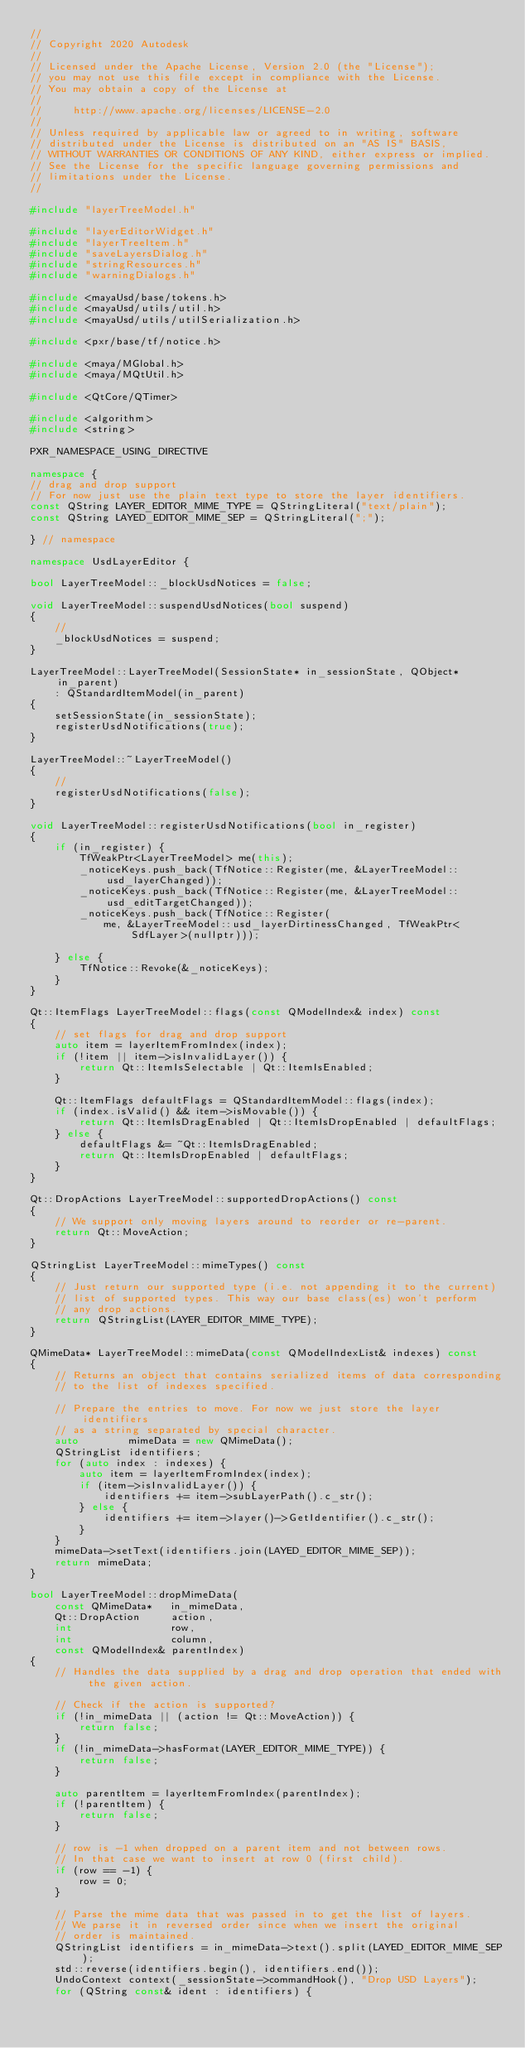Convert code to text. <code><loc_0><loc_0><loc_500><loc_500><_C++_>//
// Copyright 2020 Autodesk
//
// Licensed under the Apache License, Version 2.0 (the "License");
// you may not use this file except in compliance with the License.
// You may obtain a copy of the License at
//
//     http://www.apache.org/licenses/LICENSE-2.0
//
// Unless required by applicable law or agreed to in writing, software
// distributed under the License is distributed on an "AS IS" BASIS,
// WITHOUT WARRANTIES OR CONDITIONS OF ANY KIND, either express or implied.
// See the License for the specific language governing permissions and
// limitations under the License.
//

#include "layerTreeModel.h"

#include "layerEditorWidget.h"
#include "layerTreeItem.h"
#include "saveLayersDialog.h"
#include "stringResources.h"
#include "warningDialogs.h"

#include <mayaUsd/base/tokens.h>
#include <mayaUsd/utils/util.h>
#include <mayaUsd/utils/utilSerialization.h>

#include <pxr/base/tf/notice.h>

#include <maya/MGlobal.h>
#include <maya/MQtUtil.h>

#include <QtCore/QTimer>

#include <algorithm>
#include <string>

PXR_NAMESPACE_USING_DIRECTIVE

namespace {
// drag and drop support
// For now just use the plain text type to store the layer identifiers.
const QString LAYER_EDITOR_MIME_TYPE = QStringLiteral("text/plain");
const QString LAYED_EDITOR_MIME_SEP = QStringLiteral(";");

} // namespace

namespace UsdLayerEditor {

bool LayerTreeModel::_blockUsdNotices = false;

void LayerTreeModel::suspendUsdNotices(bool suspend)
{
    //
    _blockUsdNotices = suspend;
}

LayerTreeModel::LayerTreeModel(SessionState* in_sessionState, QObject* in_parent)
    : QStandardItemModel(in_parent)
{
    setSessionState(in_sessionState);
    registerUsdNotifications(true);
}

LayerTreeModel::~LayerTreeModel()
{
    //
    registerUsdNotifications(false);
}

void LayerTreeModel::registerUsdNotifications(bool in_register)
{
    if (in_register) {
        TfWeakPtr<LayerTreeModel> me(this);
        _noticeKeys.push_back(TfNotice::Register(me, &LayerTreeModel::usd_layerChanged));
        _noticeKeys.push_back(TfNotice::Register(me, &LayerTreeModel::usd_editTargetChanged));
        _noticeKeys.push_back(TfNotice::Register(
            me, &LayerTreeModel::usd_layerDirtinessChanged, TfWeakPtr<SdfLayer>(nullptr)));

    } else {
        TfNotice::Revoke(&_noticeKeys);
    }
}

Qt::ItemFlags LayerTreeModel::flags(const QModelIndex& index) const
{
    // set flags for drag and drop support
    auto item = layerItemFromIndex(index);
    if (!item || item->isInvalidLayer()) {
        return Qt::ItemIsSelectable | Qt::ItemIsEnabled;
    }

    Qt::ItemFlags defaultFlags = QStandardItemModel::flags(index);
    if (index.isValid() && item->isMovable()) {
        return Qt::ItemIsDragEnabled | Qt::ItemIsDropEnabled | defaultFlags;
    } else {
        defaultFlags &= ~Qt::ItemIsDragEnabled;
        return Qt::ItemIsDropEnabled | defaultFlags;
    }
}

Qt::DropActions LayerTreeModel::supportedDropActions() const
{
    // We support only moving layers around to reorder or re-parent.
    return Qt::MoveAction;
}

QStringList LayerTreeModel::mimeTypes() const
{
    // Just return our supported type (i.e. not appending it to the current)
    // list of supported types. This way our base class(es) won't perform
    // any drop actions.
    return QStringList(LAYER_EDITOR_MIME_TYPE);
}

QMimeData* LayerTreeModel::mimeData(const QModelIndexList& indexes) const
{
    // Returns an object that contains serialized items of data corresponding
    // to the list of indexes specified.

    // Prepare the entries to move. For now we just store the layer identifiers
    // as a string separated by special character.
    auto        mimeData = new QMimeData();
    QStringList identifiers;
    for (auto index : indexes) {
        auto item = layerItemFromIndex(index);
        if (item->isInvalidLayer()) {
            identifiers += item->subLayerPath().c_str();
        } else {
            identifiers += item->layer()->GetIdentifier().c_str();
        }
    }
    mimeData->setText(identifiers.join(LAYED_EDITOR_MIME_SEP));
    return mimeData;
}

bool LayerTreeModel::dropMimeData(
    const QMimeData*   in_mimeData,
    Qt::DropAction     action,
    int                row,
    int                column,
    const QModelIndex& parentIndex)
{
    // Handles the data supplied by a drag and drop operation that ended with the given action.

    // Check if the action is supported?
    if (!in_mimeData || (action != Qt::MoveAction)) {
        return false;
    }
    if (!in_mimeData->hasFormat(LAYER_EDITOR_MIME_TYPE)) {
        return false;
    }

    auto parentItem = layerItemFromIndex(parentIndex);
    if (!parentItem) {
        return false;
    }

    // row is -1 when dropped on a parent item and not between rows.
    // In that case we want to insert at row 0 (first child).
    if (row == -1) {
        row = 0;
    }

    // Parse the mime data that was passed in to get the list of layers.
    // We parse it in reversed order since when we insert the original
    // order is maintained.
    QStringList identifiers = in_mimeData->text().split(LAYED_EDITOR_MIME_SEP);
    std::reverse(identifiers.begin(), identifiers.end());
    UndoContext context(_sessionState->commandHook(), "Drop USD Layers");
    for (QString const& ident : identifiers) {</code> 